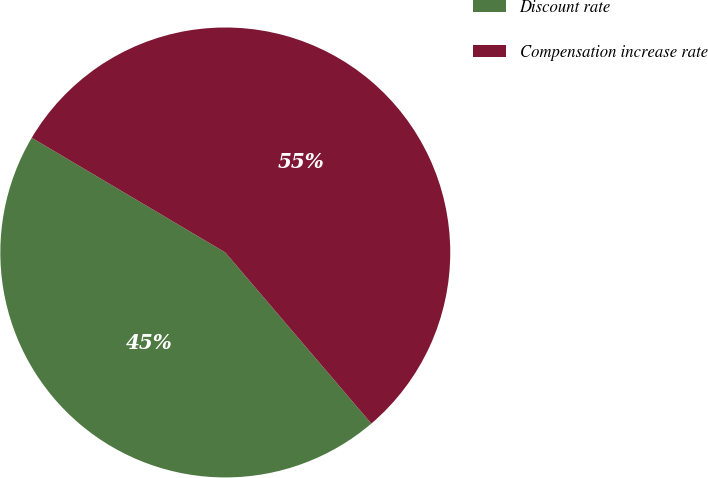Convert chart. <chart><loc_0><loc_0><loc_500><loc_500><pie_chart><fcel>Discount rate<fcel>Compensation increase rate<nl><fcel>44.76%<fcel>55.24%<nl></chart> 